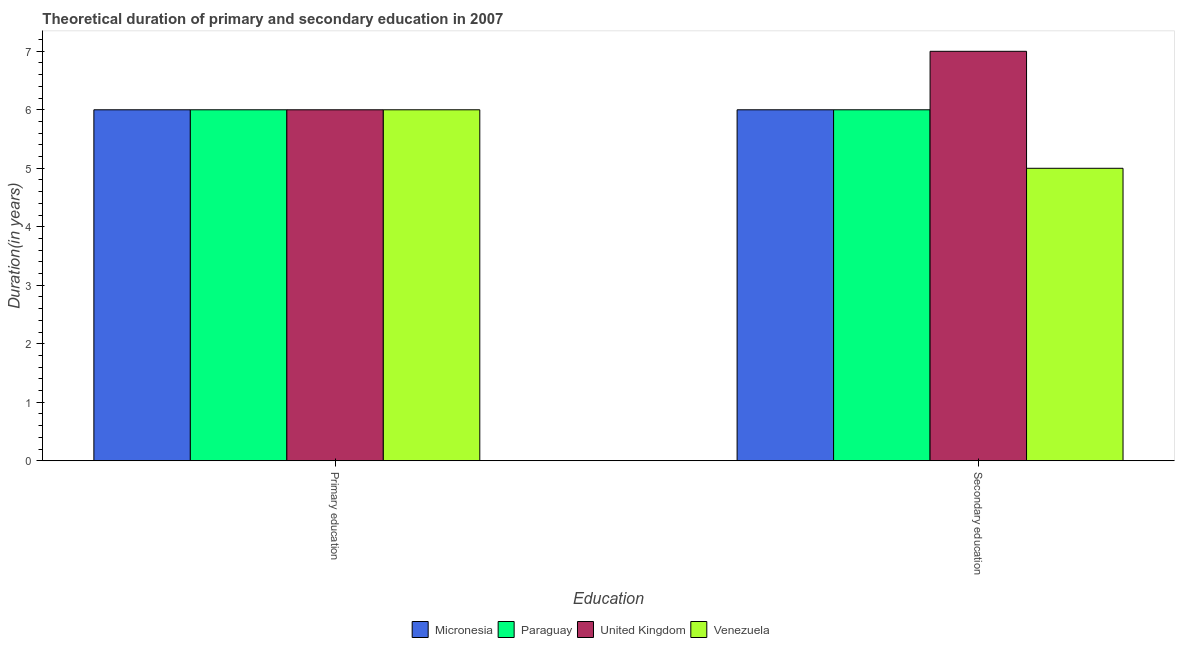How many different coloured bars are there?
Your response must be concise. 4. How many groups of bars are there?
Provide a succinct answer. 2. Are the number of bars on each tick of the X-axis equal?
Keep it short and to the point. Yes. How many bars are there on the 1st tick from the left?
Your answer should be compact. 4. How many bars are there on the 1st tick from the right?
Give a very brief answer. 4. Across all countries, what is the maximum duration of primary education?
Offer a terse response. 6. In which country was the duration of primary education maximum?
Keep it short and to the point. Micronesia. In which country was the duration of primary education minimum?
Ensure brevity in your answer.  Micronesia. What is the total duration of primary education in the graph?
Give a very brief answer. 24. What is the difference between the duration of primary education in Venezuela and the duration of secondary education in Paraguay?
Offer a very short reply. 0. What is the average duration of primary education per country?
Ensure brevity in your answer.  6. What is the difference between the duration of primary education and duration of secondary education in United Kingdom?
Your response must be concise. -1. What is the ratio of the duration of secondary education in Micronesia to that in United Kingdom?
Offer a terse response. 0.86. Is the duration of primary education in United Kingdom less than that in Paraguay?
Provide a short and direct response. No. In how many countries, is the duration of secondary education greater than the average duration of secondary education taken over all countries?
Your answer should be compact. 1. What does the 1st bar from the left in Primary education represents?
Make the answer very short. Micronesia. What does the 4th bar from the right in Primary education represents?
Offer a very short reply. Micronesia. Are the values on the major ticks of Y-axis written in scientific E-notation?
Your answer should be compact. No. Does the graph contain grids?
Provide a succinct answer. No. Where does the legend appear in the graph?
Keep it short and to the point. Bottom center. How many legend labels are there?
Make the answer very short. 4. How are the legend labels stacked?
Ensure brevity in your answer.  Horizontal. What is the title of the graph?
Your response must be concise. Theoretical duration of primary and secondary education in 2007. Does "Yemen, Rep." appear as one of the legend labels in the graph?
Your answer should be compact. No. What is the label or title of the X-axis?
Give a very brief answer. Education. What is the label or title of the Y-axis?
Provide a short and direct response. Duration(in years). What is the Duration(in years) in Micronesia in Primary education?
Keep it short and to the point. 6. What is the Duration(in years) in United Kingdom in Primary education?
Provide a succinct answer. 6. What is the Duration(in years) in Venezuela in Primary education?
Ensure brevity in your answer.  6. What is the Duration(in years) in Micronesia in Secondary education?
Make the answer very short. 6. Across all Education, what is the maximum Duration(in years) of Paraguay?
Offer a very short reply. 6. Across all Education, what is the minimum Duration(in years) of Micronesia?
Offer a terse response. 6. Across all Education, what is the minimum Duration(in years) in United Kingdom?
Offer a very short reply. 6. Across all Education, what is the minimum Duration(in years) of Venezuela?
Provide a short and direct response. 5. What is the total Duration(in years) of Micronesia in the graph?
Provide a succinct answer. 12. What is the total Duration(in years) of United Kingdom in the graph?
Your answer should be very brief. 13. What is the total Duration(in years) of Venezuela in the graph?
Your answer should be very brief. 11. What is the difference between the Duration(in years) in United Kingdom in Primary education and that in Secondary education?
Provide a succinct answer. -1. What is the difference between the Duration(in years) of Venezuela in Primary education and that in Secondary education?
Provide a succinct answer. 1. What is the difference between the Duration(in years) of Micronesia in Primary education and the Duration(in years) of Venezuela in Secondary education?
Offer a terse response. 1. What is the difference between the Duration(in years) in Paraguay in Primary education and the Duration(in years) in United Kingdom in Secondary education?
Offer a terse response. -1. What is the difference between the Duration(in years) in United Kingdom in Primary education and the Duration(in years) in Venezuela in Secondary education?
Offer a terse response. 1. What is the average Duration(in years) in Micronesia per Education?
Your answer should be compact. 6. What is the average Duration(in years) of Paraguay per Education?
Make the answer very short. 6. What is the difference between the Duration(in years) in Micronesia and Duration(in years) in Venezuela in Primary education?
Your response must be concise. 0. What is the difference between the Duration(in years) of Paraguay and Duration(in years) of United Kingdom in Primary education?
Offer a terse response. 0. What is the difference between the Duration(in years) of Paraguay and Duration(in years) of Venezuela in Primary education?
Your answer should be compact. 0. What is the difference between the Duration(in years) in Micronesia and Duration(in years) in United Kingdom in Secondary education?
Provide a short and direct response. -1. What is the difference between the Duration(in years) of United Kingdom and Duration(in years) of Venezuela in Secondary education?
Ensure brevity in your answer.  2. What is the ratio of the Duration(in years) of Micronesia in Primary education to that in Secondary education?
Offer a very short reply. 1. What is the ratio of the Duration(in years) in Venezuela in Primary education to that in Secondary education?
Your response must be concise. 1.2. What is the difference between the highest and the second highest Duration(in years) of Micronesia?
Your response must be concise. 0. What is the difference between the highest and the second highest Duration(in years) of Paraguay?
Offer a very short reply. 0. What is the difference between the highest and the second highest Duration(in years) in United Kingdom?
Provide a short and direct response. 1. What is the difference between the highest and the second highest Duration(in years) in Venezuela?
Provide a short and direct response. 1. What is the difference between the highest and the lowest Duration(in years) in United Kingdom?
Ensure brevity in your answer.  1. What is the difference between the highest and the lowest Duration(in years) of Venezuela?
Offer a very short reply. 1. 